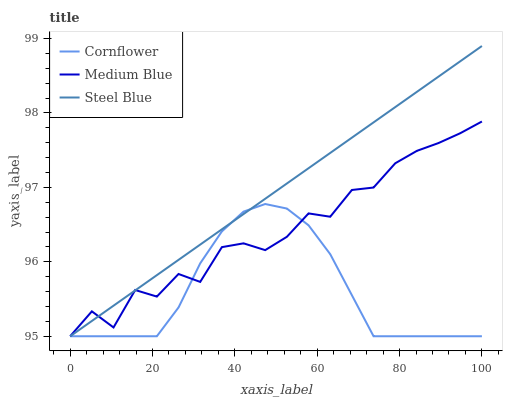Does Cornflower have the minimum area under the curve?
Answer yes or no. Yes. Does Steel Blue have the maximum area under the curve?
Answer yes or no. Yes. Does Medium Blue have the minimum area under the curve?
Answer yes or no. No. Does Medium Blue have the maximum area under the curve?
Answer yes or no. No. Is Steel Blue the smoothest?
Answer yes or no. Yes. Is Medium Blue the roughest?
Answer yes or no. Yes. Is Medium Blue the smoothest?
Answer yes or no. No. Is Steel Blue the roughest?
Answer yes or no. No. Does Cornflower have the lowest value?
Answer yes or no. Yes. Does Steel Blue have the highest value?
Answer yes or no. Yes. Does Medium Blue have the highest value?
Answer yes or no. No. Does Steel Blue intersect Medium Blue?
Answer yes or no. Yes. Is Steel Blue less than Medium Blue?
Answer yes or no. No. Is Steel Blue greater than Medium Blue?
Answer yes or no. No. 